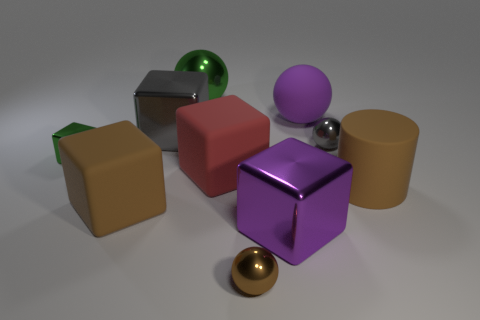The large metal thing behind the gray shiny object to the left of the purple ball is what shape?
Offer a very short reply. Sphere. Is there anything else of the same color as the tiny cube?
Ensure brevity in your answer.  Yes. What number of things are either brown metallic objects or blue shiny cubes?
Provide a short and direct response. 1. Are there any gray metallic things that have the same size as the purple metallic thing?
Your answer should be very brief. Yes. What is the shape of the purple shiny object?
Your answer should be compact. Cube. Is the number of tiny things in front of the tiny green thing greater than the number of purple matte balls that are on the right side of the large cylinder?
Your response must be concise. Yes. There is a metallic ball on the right side of the large purple matte thing; is its color the same as the big metal cube behind the gray metallic sphere?
Keep it short and to the point. Yes. What is the shape of the gray metallic thing that is the same size as the red cube?
Provide a short and direct response. Cube. Is there a big metal object of the same shape as the large red matte thing?
Give a very brief answer. Yes. Do the purple thing in front of the brown rubber cube and the large brown thing on the left side of the gray shiny ball have the same material?
Your response must be concise. No. 